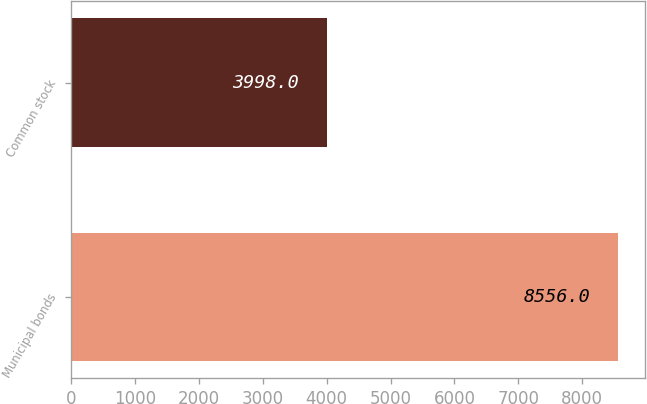Convert chart. <chart><loc_0><loc_0><loc_500><loc_500><bar_chart><fcel>Municipal bonds<fcel>Common stock<nl><fcel>8556<fcel>3998<nl></chart> 